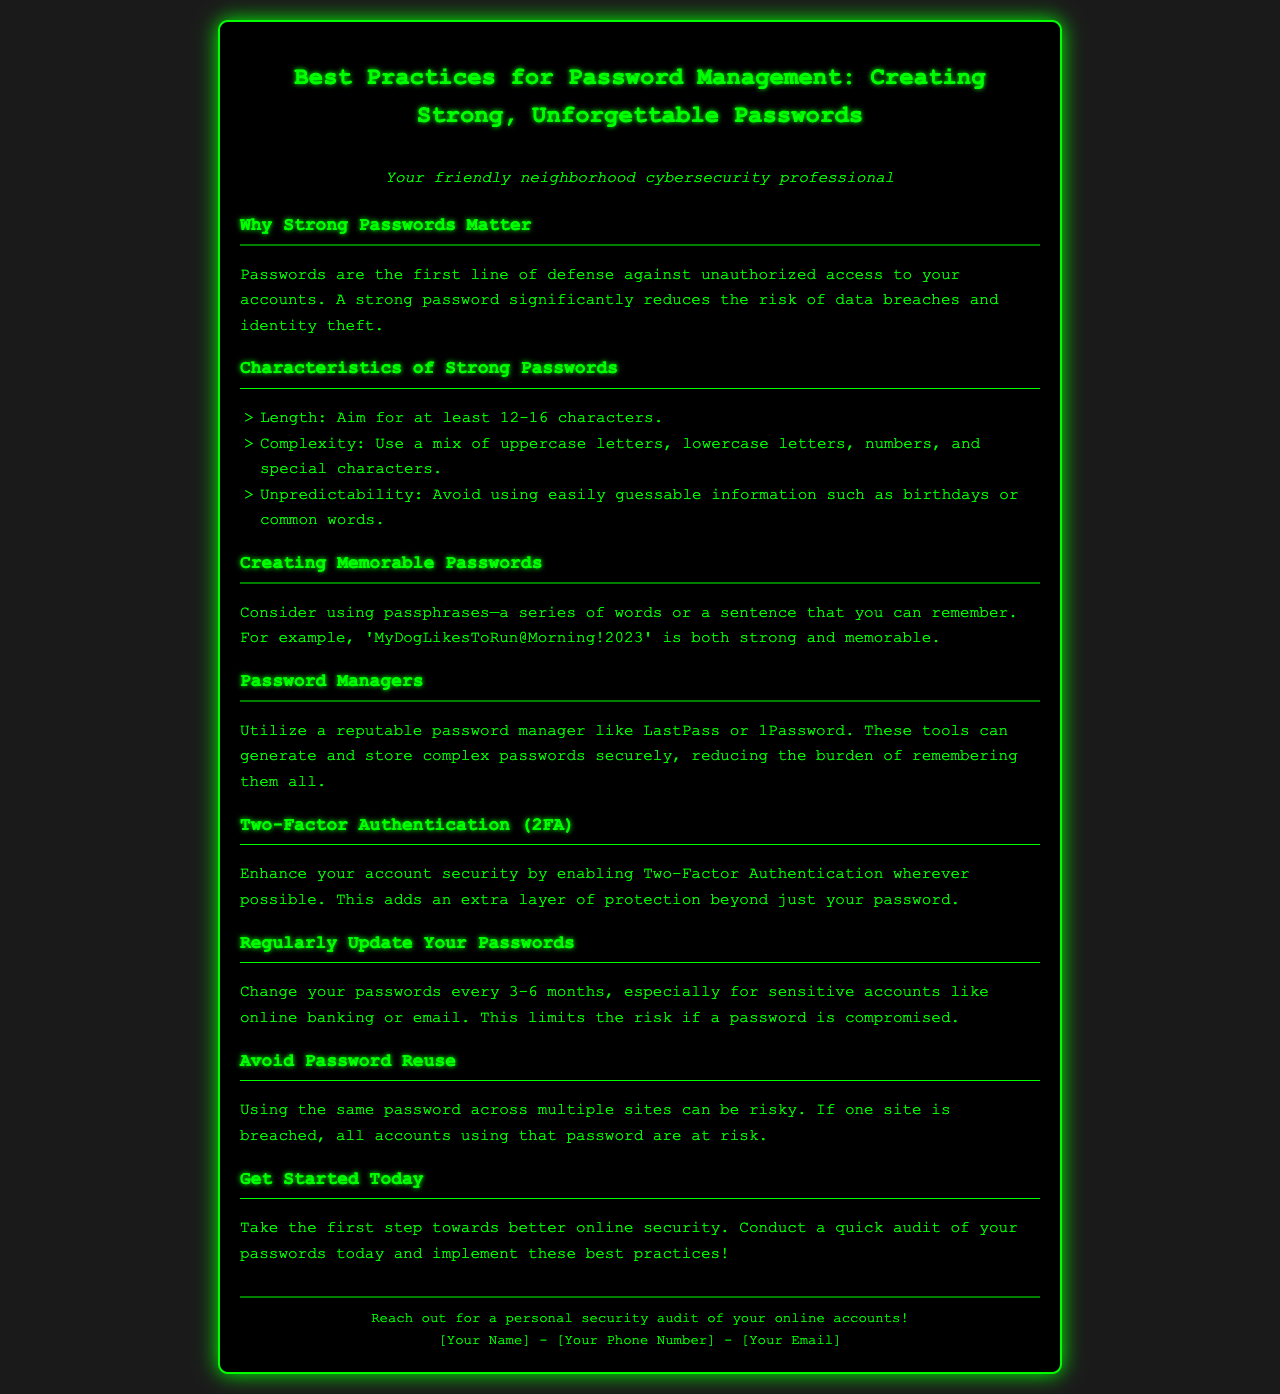What is the ideal length for strong passwords? The document states to aim for at least 12-16 characters in password length.
Answer: 12-16 characters What should be included in a strong password? The document lists uppercase letters, lowercase letters, numbers, and special characters as necessary for complexity.
Answer: Mix of character types What is an example of a memorable password provided in the document? The document gives 'MyDogLikesToRun@Morning!2023' as a strong and memorable password example.
Answer: MyDogLikesToRun@Morning!2023 How often should you change your passwords? According to the document, you should change your passwords every 3-6 months.
Answer: Every 3-6 months What is a recommended tool for managing passwords? The document suggests using a reputable password manager like LastPass or 1Password for managing passwords.
Answer: LastPass or 1Password What extra security feature is recommended in the document? The document advises enabling Two-Factor Authentication for enhanced account security.
Answer: Two-Factor Authentication What risk is associated with password reuse? The document explains that if one site is breached, all accounts using the same password are at risk.
Answer: All accounts at risk What is the main reason to use strong passwords? The document emphasizes that strong passwords reduce the risk of data breaches and identity theft.
Answer: Reduce risk of breaches What should you do today to improve online security? The document encourages users to conduct a quick audit of their passwords to enhance security.
Answer: Conduct a password audit 